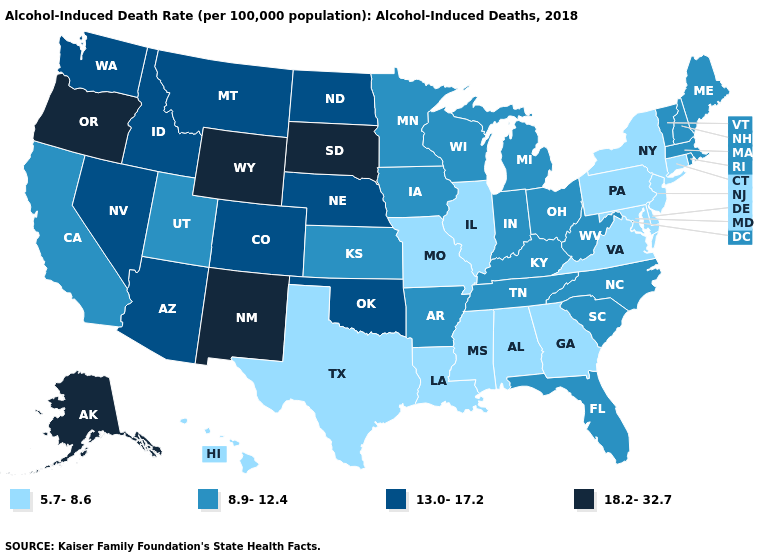Name the states that have a value in the range 5.7-8.6?
Quick response, please. Alabama, Connecticut, Delaware, Georgia, Hawaii, Illinois, Louisiana, Maryland, Mississippi, Missouri, New Jersey, New York, Pennsylvania, Texas, Virginia. Does Idaho have a lower value than Vermont?
Be succinct. No. Which states have the highest value in the USA?
Keep it brief. Alaska, New Mexico, Oregon, South Dakota, Wyoming. What is the highest value in the MidWest ?
Answer briefly. 18.2-32.7. Name the states that have a value in the range 18.2-32.7?
Concise answer only. Alaska, New Mexico, Oregon, South Dakota, Wyoming. Name the states that have a value in the range 5.7-8.6?
Keep it brief. Alabama, Connecticut, Delaware, Georgia, Hawaii, Illinois, Louisiana, Maryland, Mississippi, Missouri, New Jersey, New York, Pennsylvania, Texas, Virginia. What is the value of Utah?
Short answer required. 8.9-12.4. Does the map have missing data?
Give a very brief answer. No. Does Kentucky have a lower value than Wyoming?
Write a very short answer. Yes. What is the lowest value in states that border Minnesota?
Answer briefly. 8.9-12.4. Name the states that have a value in the range 13.0-17.2?
Write a very short answer. Arizona, Colorado, Idaho, Montana, Nebraska, Nevada, North Dakota, Oklahoma, Washington. Name the states that have a value in the range 8.9-12.4?
Write a very short answer. Arkansas, California, Florida, Indiana, Iowa, Kansas, Kentucky, Maine, Massachusetts, Michigan, Minnesota, New Hampshire, North Carolina, Ohio, Rhode Island, South Carolina, Tennessee, Utah, Vermont, West Virginia, Wisconsin. What is the highest value in states that border New Mexico?
Be succinct. 13.0-17.2. Which states have the highest value in the USA?
Short answer required. Alaska, New Mexico, Oregon, South Dakota, Wyoming. What is the lowest value in the MidWest?
Quick response, please. 5.7-8.6. 